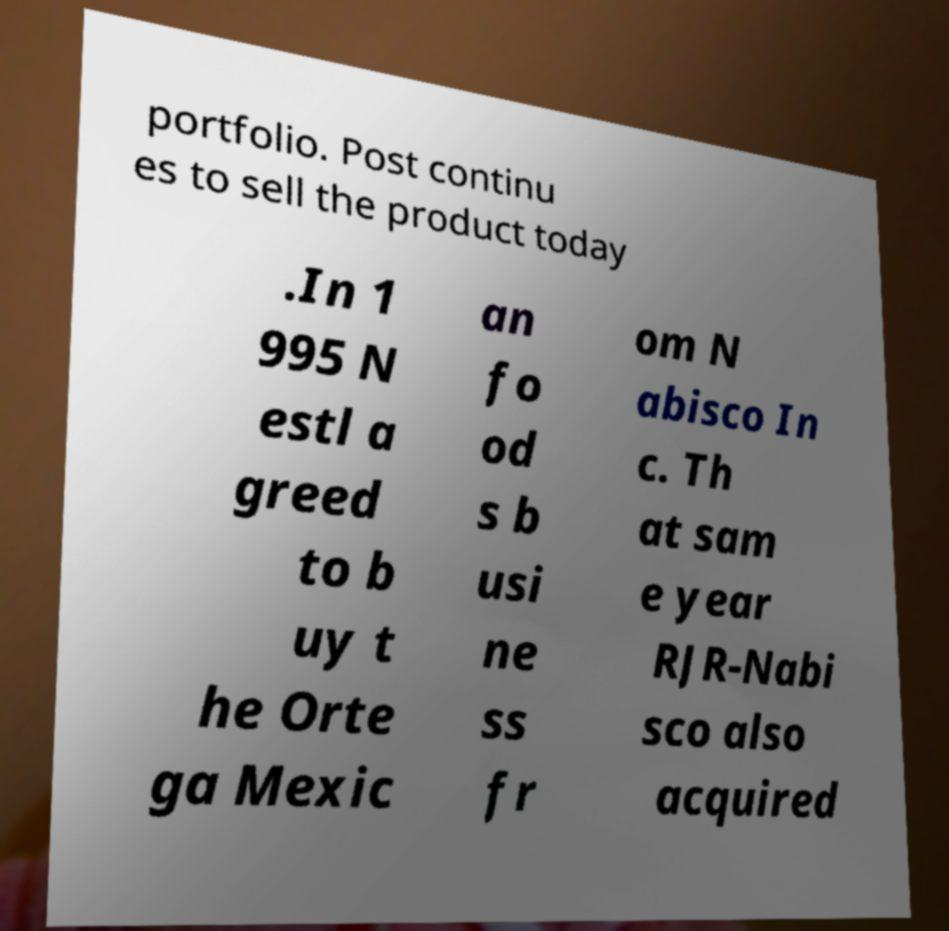For documentation purposes, I need the text within this image transcribed. Could you provide that? portfolio. Post continu es to sell the product today .In 1 995 N estl a greed to b uy t he Orte ga Mexic an fo od s b usi ne ss fr om N abisco In c. Th at sam e year RJR-Nabi sco also acquired 